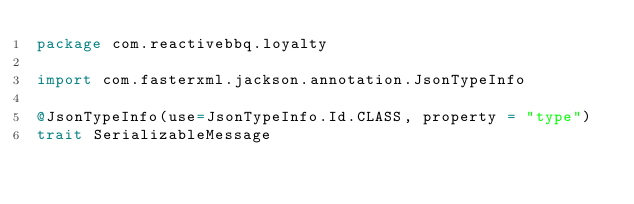Convert code to text. <code><loc_0><loc_0><loc_500><loc_500><_Scala_>package com.reactivebbq.loyalty

import com.fasterxml.jackson.annotation.JsonTypeInfo

@JsonTypeInfo(use=JsonTypeInfo.Id.CLASS, property = "type")
trait SerializableMessage
</code> 